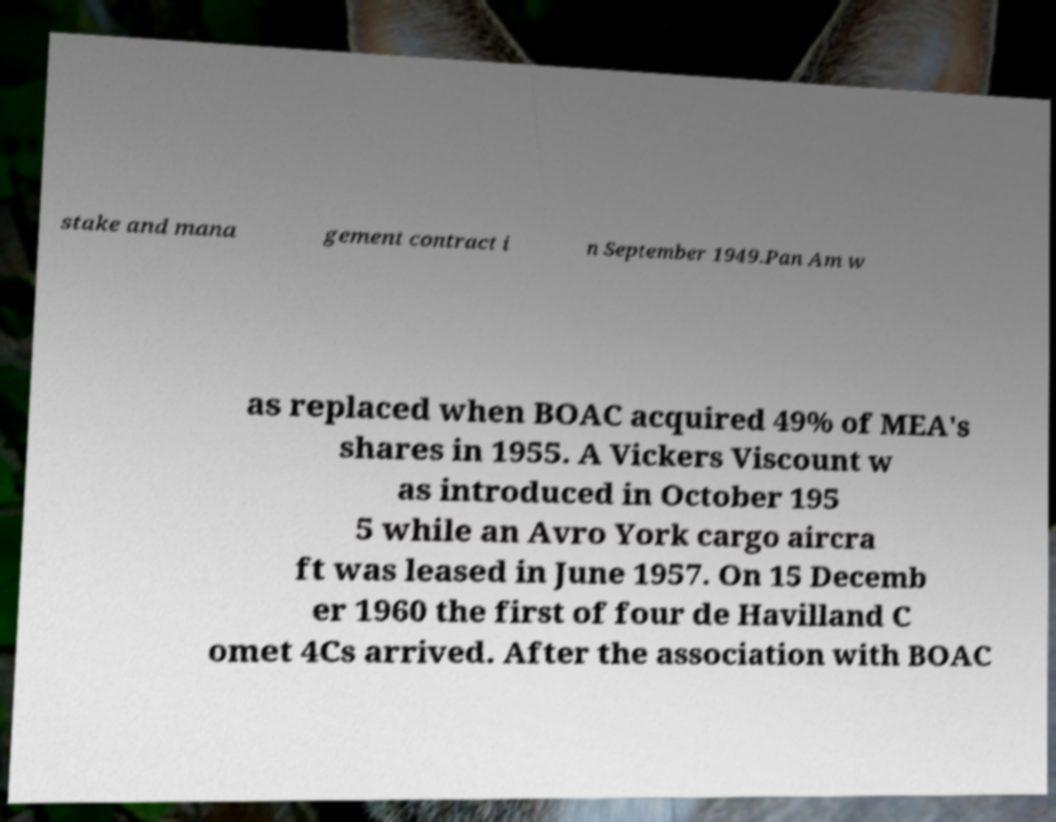What messages or text are displayed in this image? I need them in a readable, typed format. stake and mana gement contract i n September 1949.Pan Am w as replaced when BOAC acquired 49% of MEA's shares in 1955. A Vickers Viscount w as introduced in October 195 5 while an Avro York cargo aircra ft was leased in June 1957. On 15 Decemb er 1960 the first of four de Havilland C omet 4Cs arrived. After the association with BOAC 